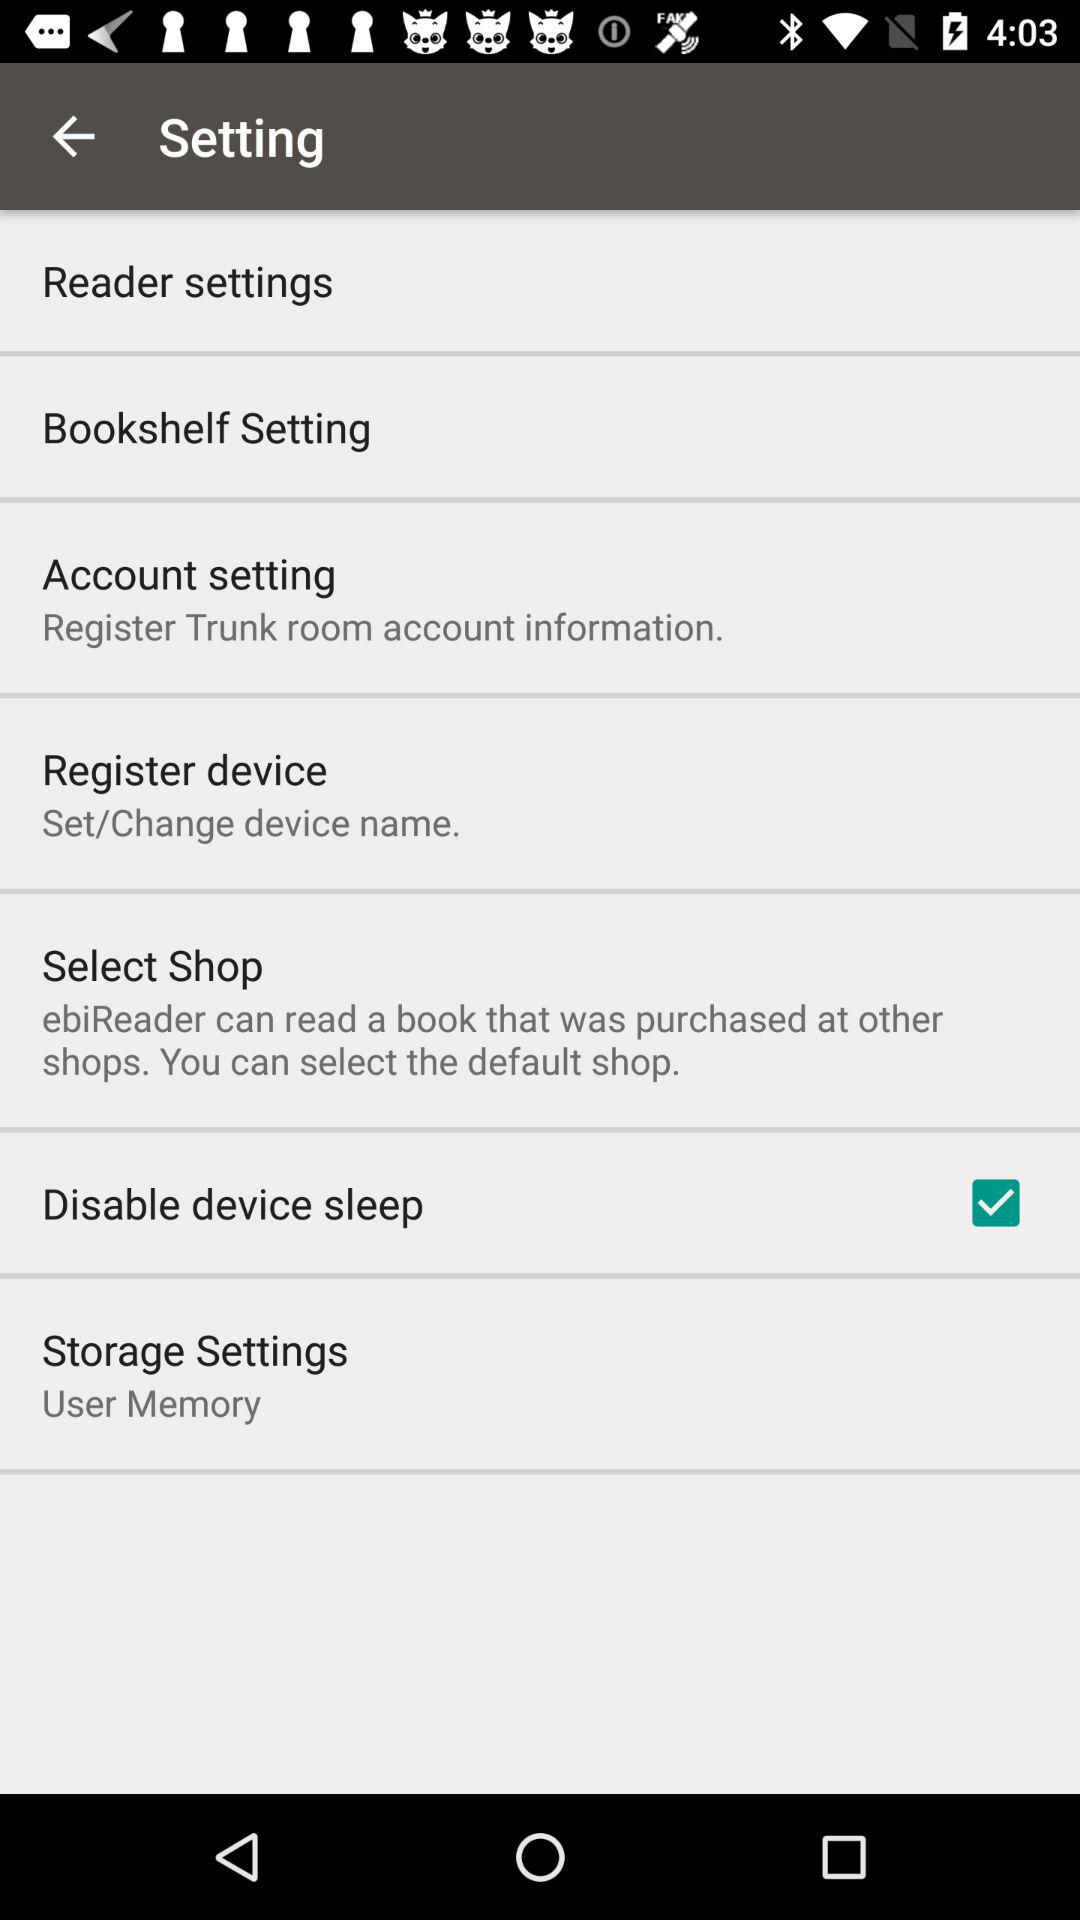What account information can be registered? The account whose information can be registered is Trunk room. 